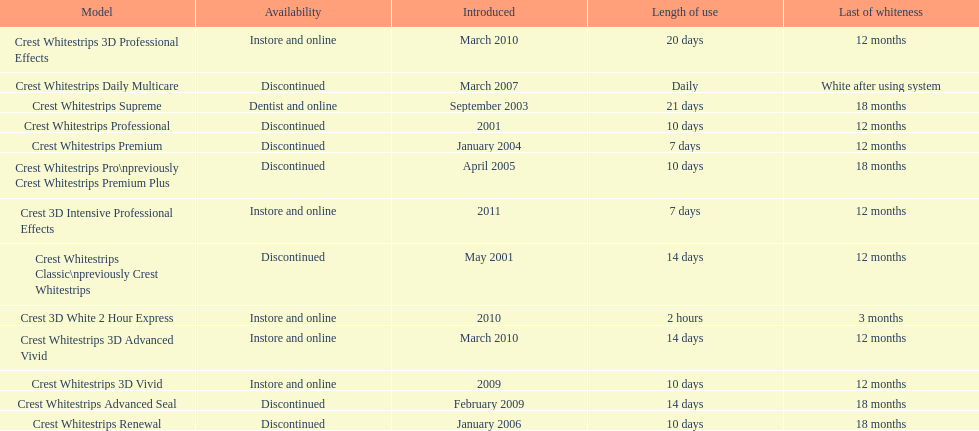What products are listed? Crest Whitestrips Classic\npreviously Crest Whitestrips, Crest Whitestrips Professional, Crest Whitestrips Supreme, Crest Whitestrips Premium, Crest Whitestrips Pro\npreviously Crest Whitestrips Premium Plus, Crest Whitestrips Renewal, Crest Whitestrips Daily Multicare, Crest Whitestrips Advanced Seal, Crest Whitestrips 3D Vivid, Crest Whitestrips 3D Advanced Vivid, Crest Whitestrips 3D Professional Effects, Crest 3D White 2 Hour Express, Crest 3D Intensive Professional Effects. Of these, which was were introduced in march, 2010? Crest Whitestrips 3D Advanced Vivid, Crest Whitestrips 3D Professional Effects. Of these, which were not 3d advanced vivid? Crest Whitestrips 3D Professional Effects. 